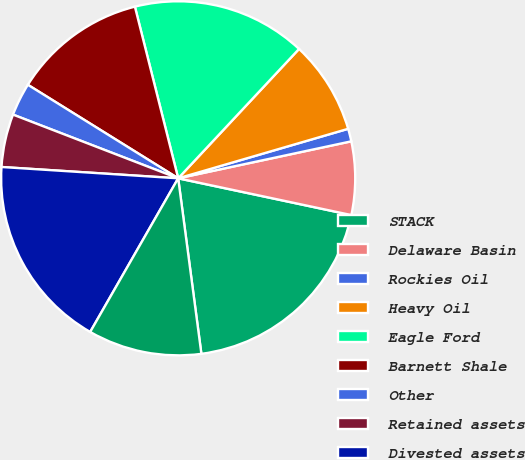Convert chart. <chart><loc_0><loc_0><loc_500><loc_500><pie_chart><fcel>STACK<fcel>Delaware Basin<fcel>Rockies Oil<fcel>Heavy Oil<fcel>Eagle Ford<fcel>Barnett Shale<fcel>Other<fcel>Retained assets<fcel>Divested assets<fcel>Total Oil<nl><fcel>19.58%<fcel>6.68%<fcel>1.16%<fcel>8.53%<fcel>15.89%<fcel>12.21%<fcel>3.0%<fcel>4.84%<fcel>17.74%<fcel>10.37%<nl></chart> 